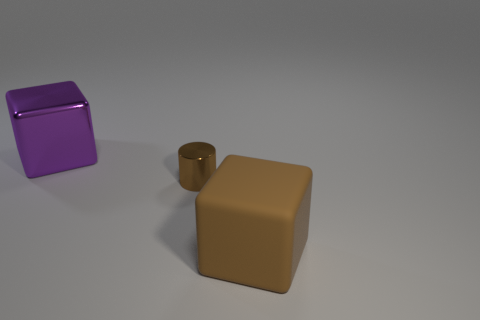The matte object has what size?
Offer a terse response. Large. What number of brown things are large rubber things or large cubes?
Offer a very short reply. 1. What number of other brown matte things have the same shape as the brown matte object?
Provide a short and direct response. 0. How many metallic blocks are the same size as the brown metal cylinder?
Make the answer very short. 0. There is a big brown object that is the same shape as the purple thing; what is its material?
Ensure brevity in your answer.  Rubber. There is a thing that is behind the tiny brown cylinder; what is its color?
Keep it short and to the point. Purple. Is the number of tiny things that are on the left side of the small shiny cylinder greater than the number of yellow matte cubes?
Give a very brief answer. No. What color is the metal cylinder?
Give a very brief answer. Brown. What is the shape of the shiny object that is in front of the large object that is on the left side of the large object that is to the right of the purple metallic cube?
Keep it short and to the point. Cylinder. There is a object that is on the left side of the brown rubber thing and in front of the big purple metallic object; what is it made of?
Provide a succinct answer. Metal. 